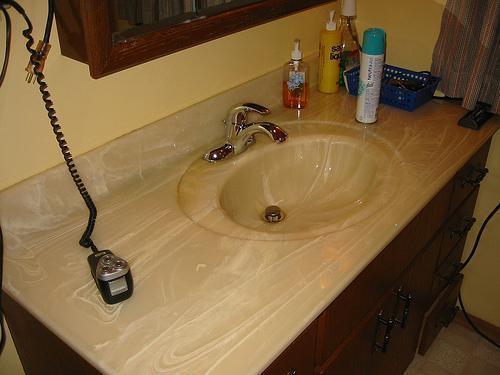How many mirrors are in the room?
Give a very brief answer. 1. 